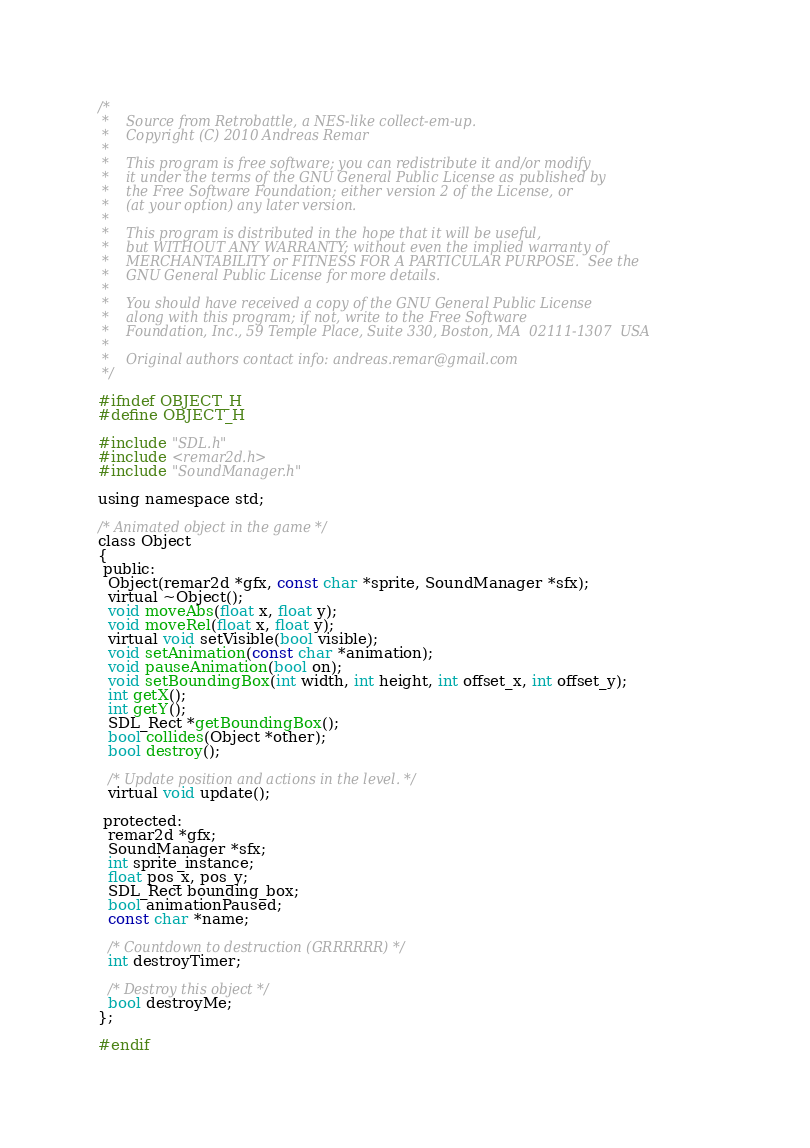Convert code to text. <code><loc_0><loc_0><loc_500><loc_500><_C_>/*
 *    Source from Retrobattle, a NES-like collect-em-up.
 *    Copyright (C) 2010 Andreas Remar
 *
 *    This program is free software; you can redistribute it and/or modify
 *    it under the terms of the GNU General Public License as published by
 *    the Free Software Foundation; either version 2 of the License, or
 *    (at your option) any later version.
 *
 *    This program is distributed in the hope that it will be useful,
 *    but WITHOUT ANY WARRANTY; without even the implied warranty of
 *    MERCHANTABILITY or FITNESS FOR A PARTICULAR PURPOSE.  See the
 *    GNU General Public License for more details.
 *
 *    You should have received a copy of the GNU General Public License
 *    along with this program; if not, write to the Free Software
 *    Foundation, Inc., 59 Temple Place, Suite 330, Boston, MA  02111-1307  USA
 *
 *    Original authors contact info: andreas.remar@gmail.com
 */

#ifndef OBJECT_H
#define OBJECT_H

#include "SDL.h"
#include <remar2d.h>
#include "SoundManager.h"

using namespace std;

/* Animated object in the game */
class Object
{
 public:
  Object(remar2d *gfx, const char *sprite, SoundManager *sfx);
  virtual ~Object();
  void moveAbs(float x, float y);
  void moveRel(float x, float y);
  virtual void setVisible(bool visible);
  void setAnimation(const char *animation);
  void pauseAnimation(bool on);
  void setBoundingBox(int width, int height, int offset_x, int offset_y);
  int getX();
  int getY();
  SDL_Rect *getBoundingBox();
  bool collides(Object *other);
  bool destroy();

  /* Update position and actions in the level. */
  virtual void update();

 protected:
  remar2d *gfx;
  SoundManager *sfx;
  int sprite_instance;
  float pos_x, pos_y;
  SDL_Rect bounding_box;
  bool animationPaused;
  const char *name;

  /* Countdown to destruction (GRRRRRR) */
  int destroyTimer;

  /* Destroy this object */
  bool destroyMe;
};

#endif
</code> 